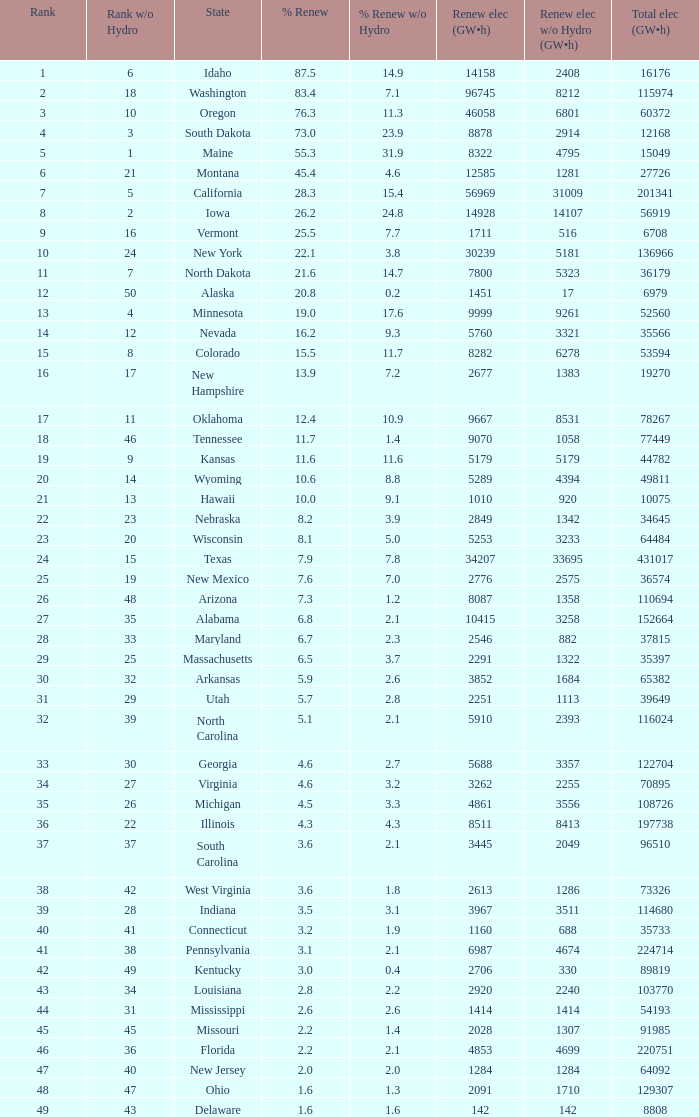In the state of south dakota, what percentage of renewable electricity comes from sources other than hydrogen power? 23.9. 